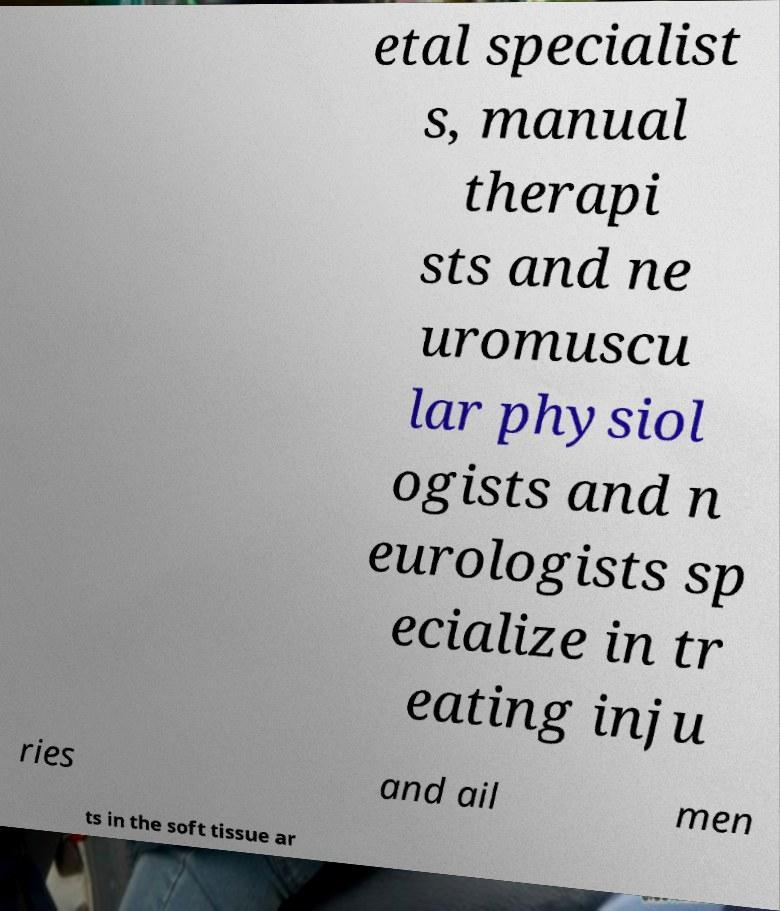Please identify and transcribe the text found in this image. etal specialist s, manual therapi sts and ne uromuscu lar physiol ogists and n eurologists sp ecialize in tr eating inju ries and ail men ts in the soft tissue ar 